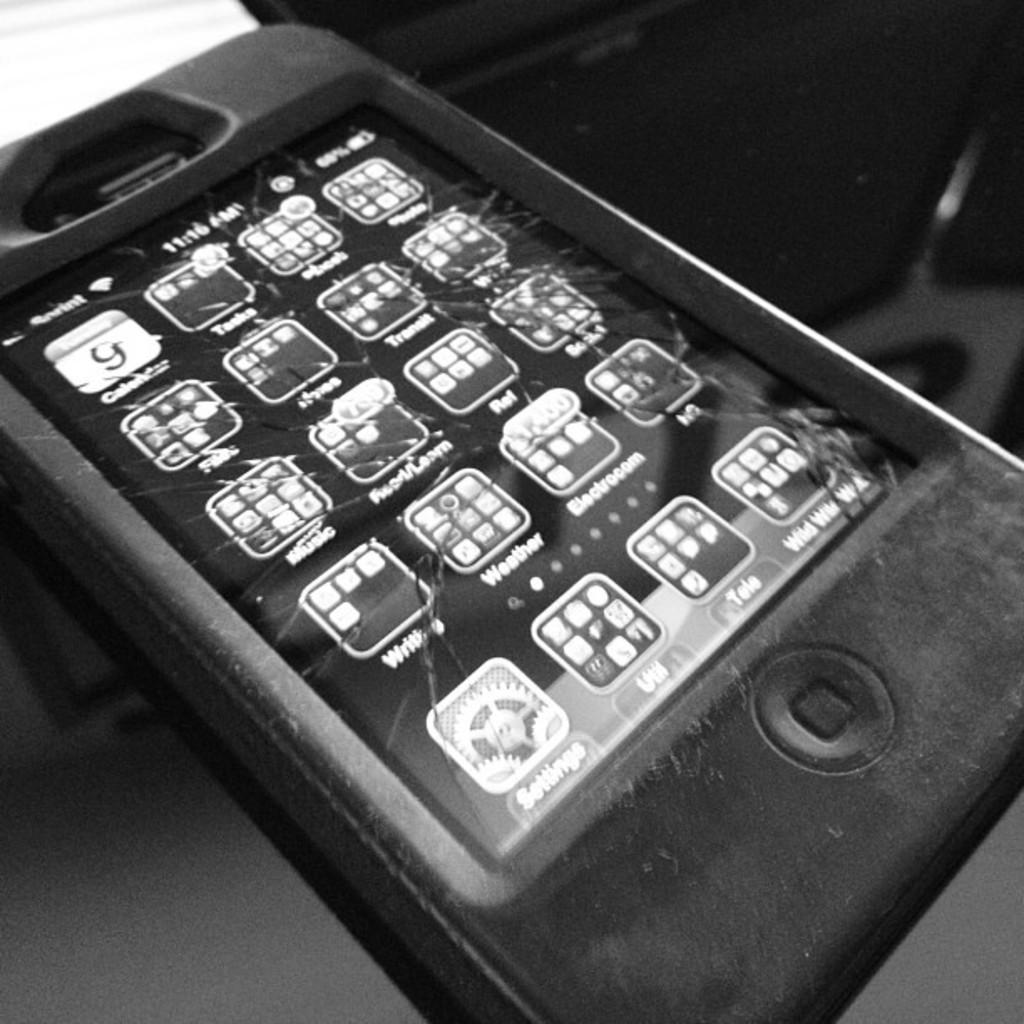What is the color scheme of the image? The image is black and white. What can be seen in the image? There is a mobile in the image. What features are present on the mobile? The mobile has logos and apps. What else is visible in the image besides the mobile? There is an unspecified object beside the mobile. Can you see a river flowing in the image? No, there is no river present in the image. What shape is the square beside the mobile in the image? There is no square present in the image. 